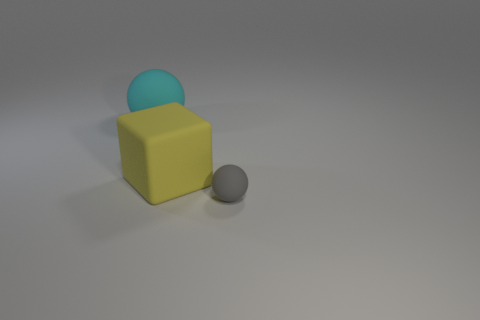Add 3 rubber blocks. How many objects exist? 6 Subtract all balls. How many objects are left? 1 Add 1 large gray matte balls. How many large gray matte balls exist? 1 Subtract 0 yellow balls. How many objects are left? 3 Subtract all tiny red spheres. Subtract all large cyan rubber spheres. How many objects are left? 2 Add 1 large cyan rubber balls. How many large cyan rubber balls are left? 2 